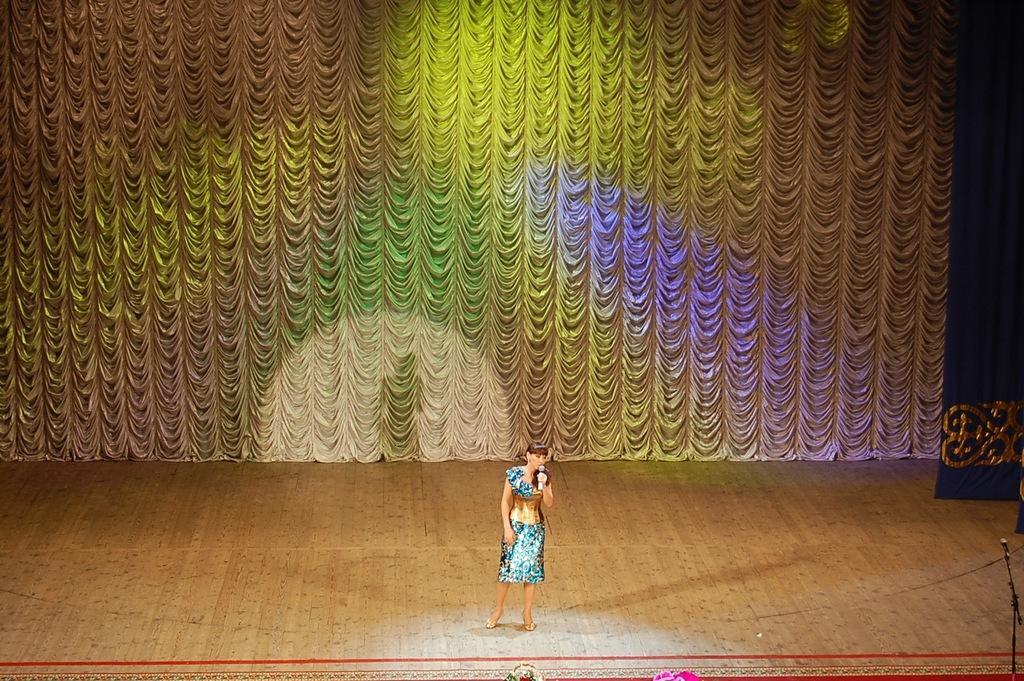How would you summarize this image in a sentence or two? In this image in the center there is one woman standing and she is holding a mike. At the bottom there is stage and in the background there is a curtain, on the right side there is a mike. 